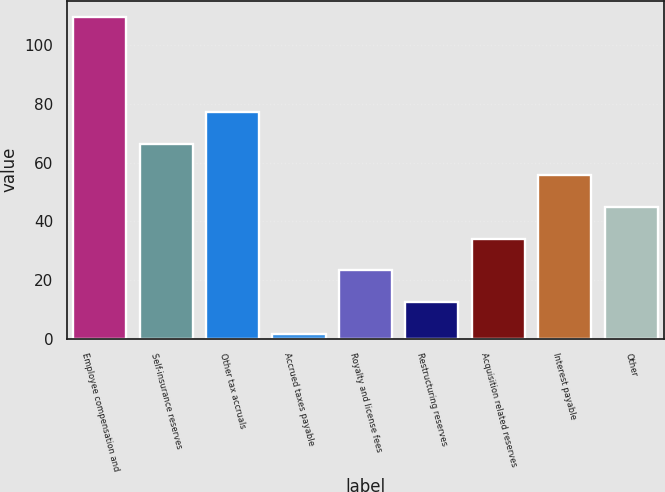Convert chart to OTSL. <chart><loc_0><loc_0><loc_500><loc_500><bar_chart><fcel>Employee compensation and<fcel>Self-insurance reserves<fcel>Other tax accruals<fcel>Accrued taxes payable<fcel>Royalty and license fees<fcel>Restructuring reserves<fcel>Acquisition related reserves<fcel>Interest payable<fcel>Other<nl><fcel>109.7<fcel>66.46<fcel>77.27<fcel>1.6<fcel>23.22<fcel>12.41<fcel>34.03<fcel>55.65<fcel>44.84<nl></chart> 